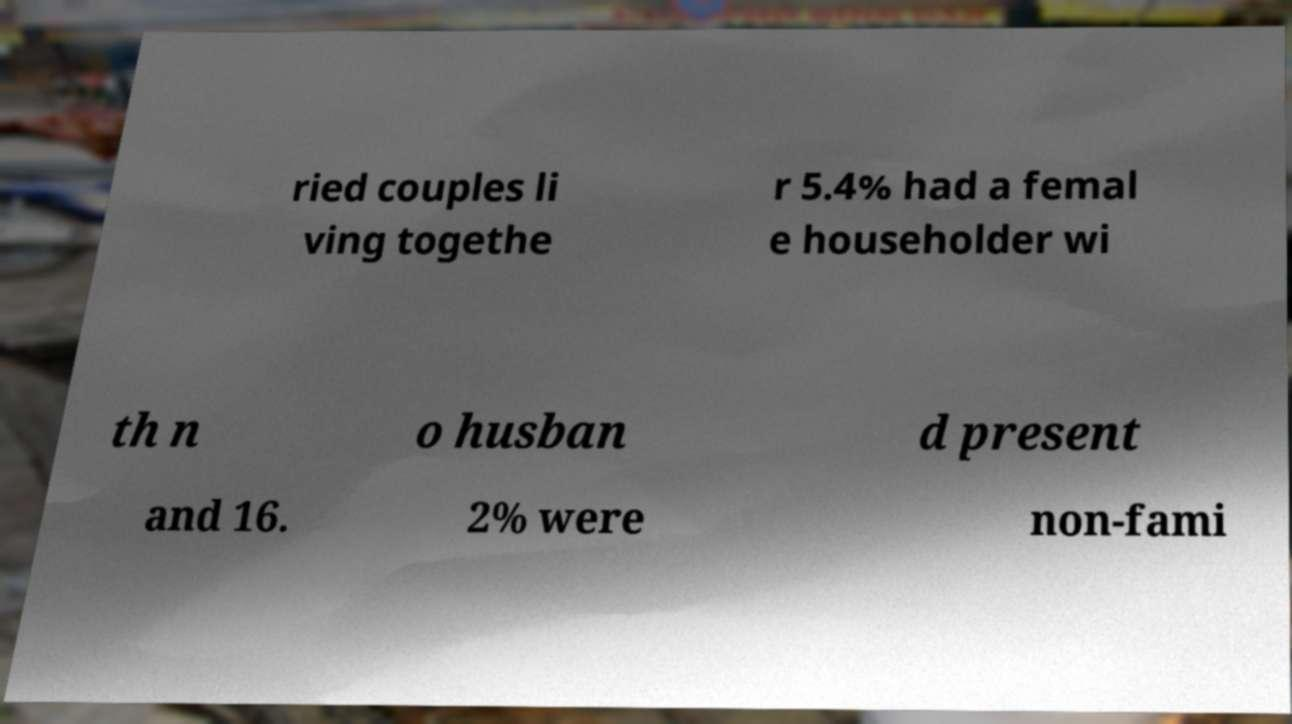For documentation purposes, I need the text within this image transcribed. Could you provide that? ried couples li ving togethe r 5.4% had a femal e householder wi th n o husban d present and 16. 2% were non-fami 